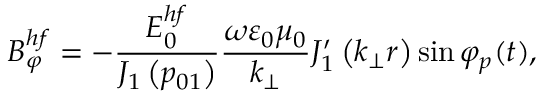Convert formula to latex. <formula><loc_0><loc_0><loc_500><loc_500>B _ { \varphi } ^ { h f } = - \frac { E _ { 0 } ^ { h f } } { J _ { 1 } \left ( p _ { 0 1 } \right ) } \frac { \omega \varepsilon _ { 0 } \mu _ { 0 } } { k _ { \perp } } J _ { 1 } ^ { \prime } \left ( k _ { \perp } r \right ) \sin \varphi _ { p } ( t ) ,</formula> 